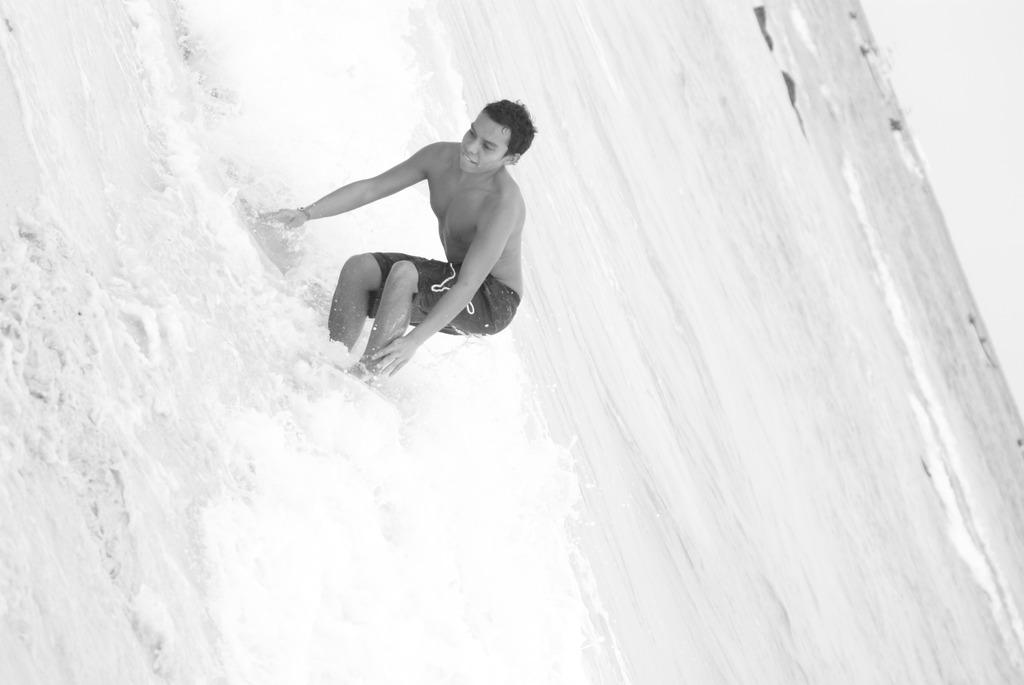What is the person in the image doing? There is a person in the water in the image. What can be observed about the water in the image? Waves are visible in the water. What type of force is being applied to the person's leg in the image? There is no force being applied to the person's leg in the image, as the person is simply in the water. 